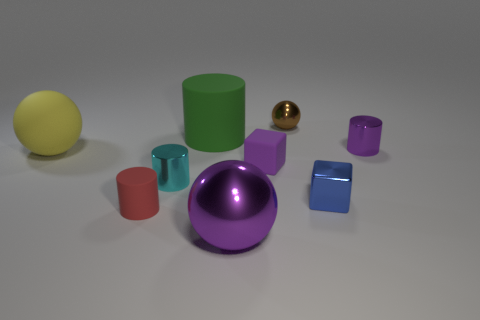What is the material of the small cylinder that is the same color as the large shiny thing?
Your answer should be very brief. Metal. What color is the large rubber object behind the small shiny cylinder that is behind the tiny purple rubber cube?
Provide a short and direct response. Green. Do the blue cube and the purple cylinder have the same size?
Make the answer very short. Yes. What is the material of the yellow thing that is the same shape as the large purple metal thing?
Offer a terse response. Rubber. How many metal cubes have the same size as the matte block?
Your answer should be very brief. 1. There is a big object that is the same material as the small purple cylinder; what color is it?
Ensure brevity in your answer.  Purple. Is the number of metal cubes less than the number of big cyan metallic cylinders?
Your answer should be compact. No. What number of yellow things are either metal cubes or rubber blocks?
Offer a very short reply. 0. What number of objects are on the left side of the brown metallic sphere and in front of the yellow ball?
Provide a succinct answer. 4. Is the large purple object made of the same material as the large yellow ball?
Give a very brief answer. No. 